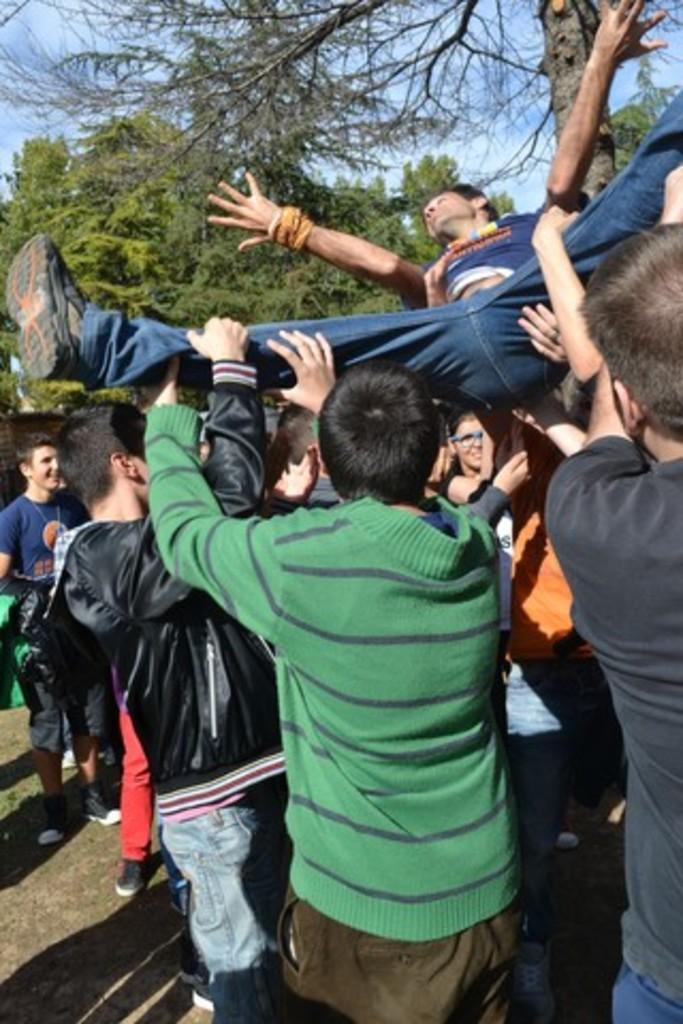Please provide a concise description of this image. In this image we can see there is a group of people standing on the ground and holding a person. At the back there are trees and the sky. 